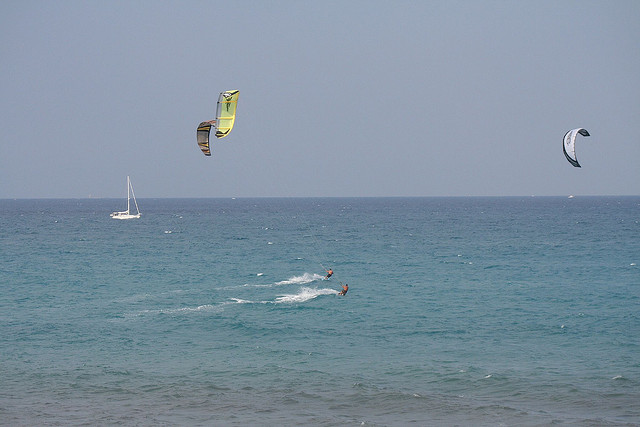Can you count how many parasails are visible? Yes, there are three parasails visible in the image, each being used by kite surfers. 